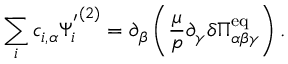<formula> <loc_0><loc_0><loc_500><loc_500>\sum _ { i } c _ { i , \alpha } { \Psi _ { i } ^ { ^ { \prime } } } ^ { ( 2 ) } = \partial _ { \beta } \left ( \frac { \mu } { p } \partial _ { \gamma } \delta \Pi _ { \alpha \beta \gamma } ^ { e q } \right ) .</formula> 